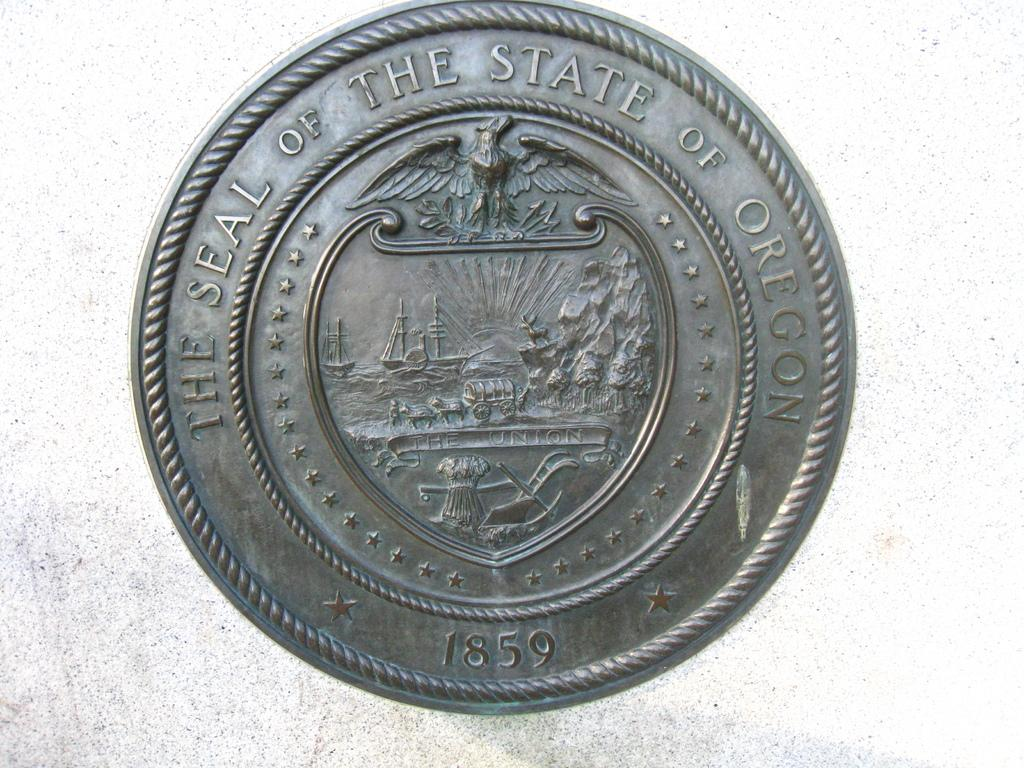<image>
Relay a brief, clear account of the picture shown. An image that appears to be quite old that displays The Seal of The State of Oregon. 